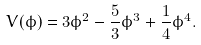<formula> <loc_0><loc_0><loc_500><loc_500>V ( \phi ) = 3 \phi ^ { 2 } - \frac { 5 } { 3 } \phi ^ { 3 } + \frac { 1 } { 4 } \phi ^ { 4 } .</formula> 